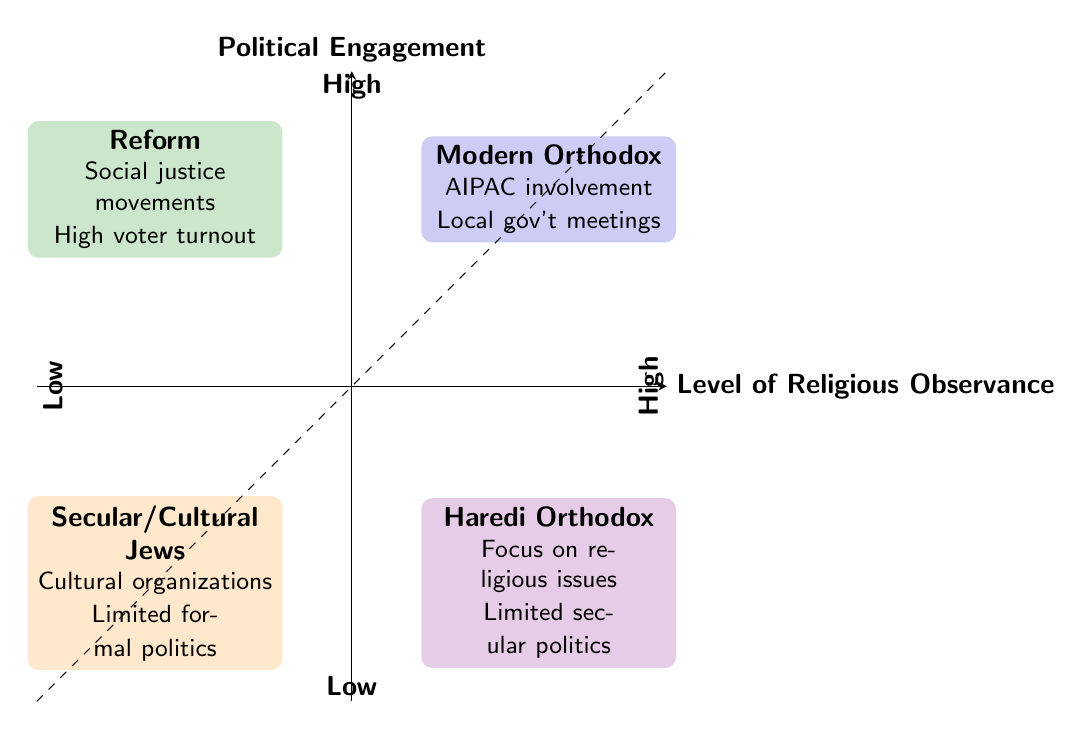What denomination has high religious observance and high political engagement? The quadrant for high religious observance and high political engagement contains the denomination "Modern Orthodox." This is determined by locating the upper right quadrant of the diagram, where the two axes intersect.
Answer: Modern Orthodox What examples are attributed to Haredi Orthodox engagement? The examples provided for the Haredi Orthodox denomination in the low engagement, high observance quadrant are "Selective focus on religious issues" and "Limited involvement in secular politics." This information is found directly in the quadrant corresponding to Haredi Orthodox.
Answer: Selective focus on religious issues, Limited involvement in secular politics Which denomination is located in the low observance, high engagement quadrant? The Reform denomination is positioned in the lower left quadrant where there is low religious observance and high political engagement. This is determined by identifying the quadrant that corresponds to these criteria.
Answer: Reform How many denominations are represented in this diagram? The diagram represents a total of four denominations; Modern Orthodox, Haredi Orthodox, Reform, and Secular/Cultural Jews. This can be counted by identifying each distinct category represented in the quadrants.
Answer: Four What trend can be observed regarding engagement and observance levels? The trend is that higher levels of religious observance correspond to higher political engagement only with Modern Orthodox, while other denominations show varying levels of engagement despite their observance. This requires synthesizing the engagement levels and observance metrics across denominations.
Answer: High observance does not guarantee high engagement Which quadrant contains the denomination with limited formal political participation? The secular/cultural Jews are situated in the low observance, low engagement quadrant, which is characterized by limited engagement in formal political processes. This is resolved by locating the quadrant that meets both "low observance" and "low engagement" criteria.
Answer: Secular/Cultural Jews What is the primary political involvement example for Reform Jews? The primary example mentioned for Reform Jews in the high engagement, low observance quadrant is "Active in social justice movements." This is derived directly from the characteristics listed in that respective quadrant.
Answer: Active in social justice movements 